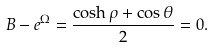<formula> <loc_0><loc_0><loc_500><loc_500>B - e ^ { \Omega } = \frac { \cosh \rho + \cos \theta } { 2 } = 0 .</formula> 